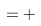Convert formula to latex. <formula><loc_0><loc_0><loc_500><loc_500>& = +</formula> 